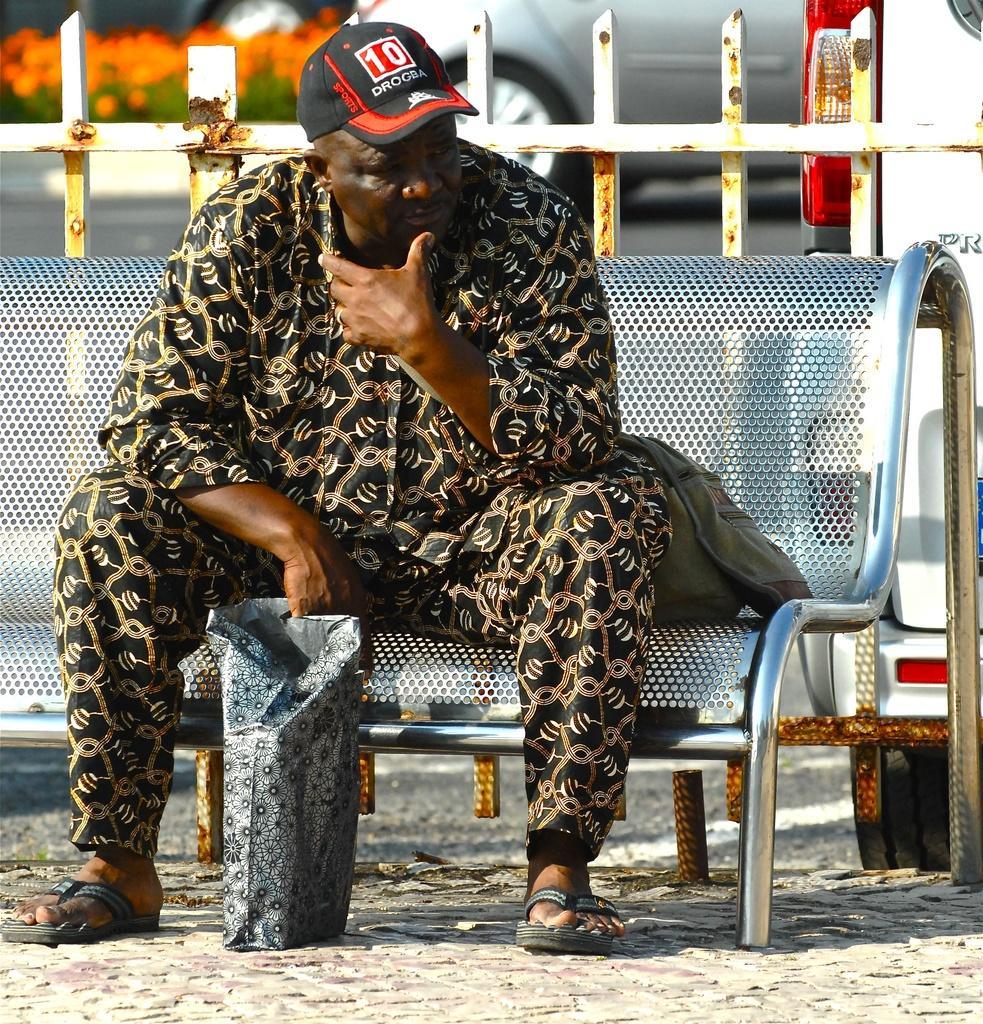Could you give a brief overview of what you see in this image? As we can see in the image in the front there is a man wearing cap and sitting on bench. In the background there is a car, plants and flowers. 